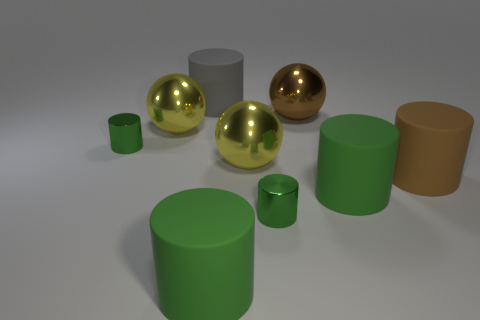How many yellow metallic spheres are the same size as the brown metal thing?
Your answer should be compact. 2. Do the gray cylinder and the large brown cylinder have the same material?
Ensure brevity in your answer.  Yes. What number of other objects are the same shape as the large brown metal thing?
Make the answer very short. 2. What color is the metal sphere that is in front of the tiny cylinder to the left of the gray rubber object?
Provide a short and direct response. Yellow. What material is the big green cylinder that is behind the green matte cylinder that is on the left side of the big brown ball?
Provide a succinct answer. Rubber. Are there any gray things right of the tiny green metal object in front of the brown matte object that is on the right side of the large gray matte cylinder?
Your response must be concise. No. How many small metal objects are in front of the brown matte object and left of the gray rubber cylinder?
Provide a succinct answer. 0. What is the shape of the big brown metal thing?
Your answer should be compact. Sphere. How many other objects are there of the same material as the big brown ball?
Keep it short and to the point. 4. There is a big cylinder that is behind the large yellow object left of the large matte cylinder behind the brown sphere; what is its color?
Your answer should be compact. Gray. 